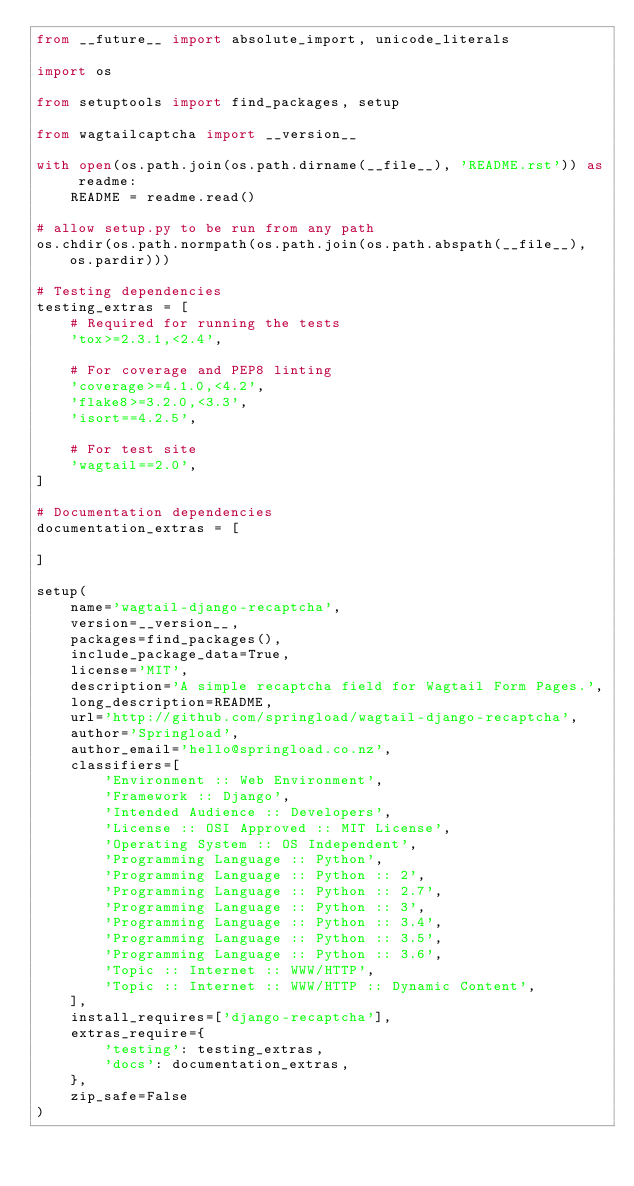<code> <loc_0><loc_0><loc_500><loc_500><_Python_>from __future__ import absolute_import, unicode_literals

import os

from setuptools import find_packages, setup

from wagtailcaptcha import __version__

with open(os.path.join(os.path.dirname(__file__), 'README.rst')) as readme:
    README = readme.read()

# allow setup.py to be run from any path
os.chdir(os.path.normpath(os.path.join(os.path.abspath(__file__), os.pardir)))

# Testing dependencies
testing_extras = [
    # Required for running the tests
    'tox>=2.3.1,<2.4',

    # For coverage and PEP8 linting
    'coverage>=4.1.0,<4.2',
    'flake8>=3.2.0,<3.3',
    'isort==4.2.5',

    # For test site
    'wagtail==2.0',
]

# Documentation dependencies
documentation_extras = [

]

setup(
    name='wagtail-django-recaptcha',
    version=__version__,
    packages=find_packages(),
    include_package_data=True,
    license='MIT',
    description='A simple recaptcha field for Wagtail Form Pages.',
    long_description=README,
    url='http://github.com/springload/wagtail-django-recaptcha',
    author='Springload',
    author_email='hello@springload.co.nz',
    classifiers=[
        'Environment :: Web Environment',
        'Framework :: Django',
        'Intended Audience :: Developers',
        'License :: OSI Approved :: MIT License',
        'Operating System :: OS Independent',
        'Programming Language :: Python',
        'Programming Language :: Python :: 2',
        'Programming Language :: Python :: 2.7',
        'Programming Language :: Python :: 3',
        'Programming Language :: Python :: 3.4',
        'Programming Language :: Python :: 3.5',
        'Programming Language :: Python :: 3.6',
        'Topic :: Internet :: WWW/HTTP',
        'Topic :: Internet :: WWW/HTTP :: Dynamic Content',
    ],
    install_requires=['django-recaptcha'],
    extras_require={
        'testing': testing_extras,
        'docs': documentation_extras,
    },
    zip_safe=False
)
</code> 